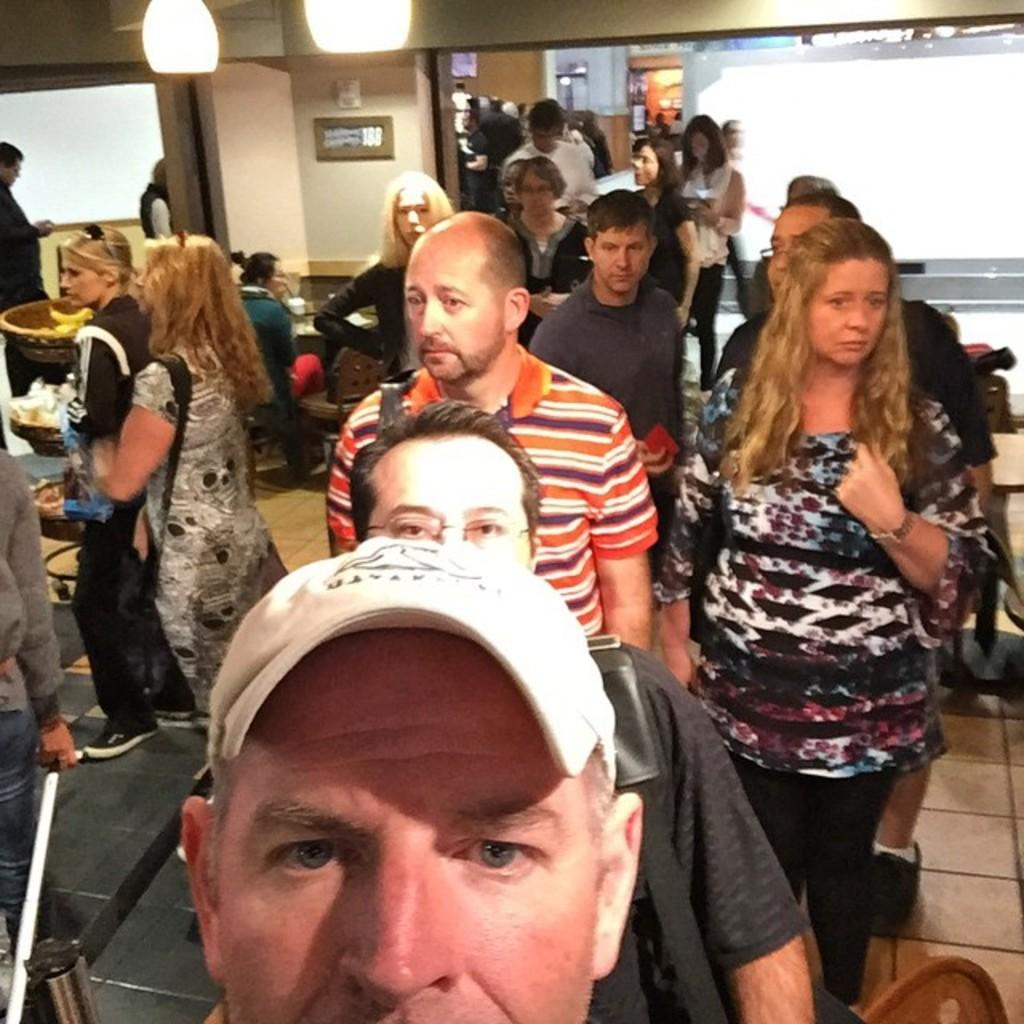What are the people in the image doing? The people in the image are standing. What is the position of the woman in the image? The woman is sitting on a chair in the image. What can be seen illuminating the scene in the image? There are lights visible in the image. What color is the crayon being used by the woman in the image? There is no crayon present in the image. What is the health condition of the people in the image? We cannot determine the health condition of the people in the image based on the provided facts. 